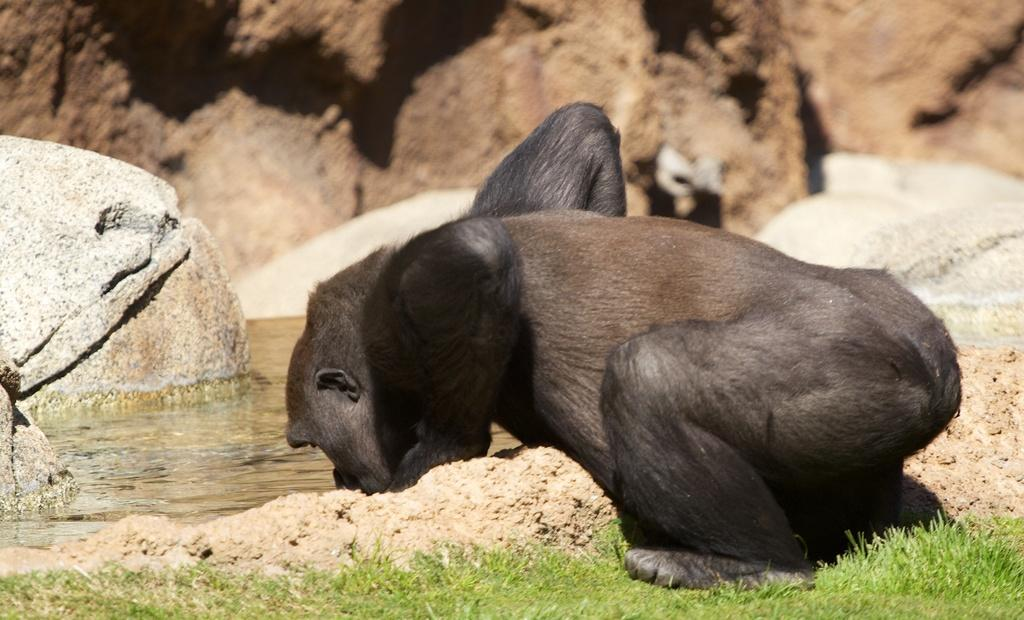What animal can be seen in the image? There is a gorilla in the image. What is the gorilla doing in the image? The gorilla is drinking water. What type of vegetation is present in the image? There is grass in the image. What other objects can be seen in the image? There are rocks in the image. How would you describe the background of the image? The background of the image is blurred. What idea does the gorilla have while drinking water in the image? There is no indication in the image that the gorilla has any ideas. --- Facts: 1. There is a person in the image. 12. The person is wearing a hat. 13. The person is holding a book. 14. There is a tree in the background. 15. The ground is visible in the image. Absurd Topics: 16. elephant, 17. bicycle, 18. umbrella Conversation: What is the main subject in the image? There is a person in the image. What is the person wearing in the image? The person is wearing a hat. What object is the person holding in the image? The person is holding a book. What can be seen in the background of the image? There is a tree in the background. What part of the natural environment is visible in the image? The ground is visible in the image. Reasoning: Let's think step by step in order to produce the conversation. We start by identifying the main subject of the image, which is a person. Next, we describe specific features of the person, such as the hat. Then, we observe the actions of the person, noting that they are holding a book. Finally, we describe the natural setting visible in the image, which includes a tree in the background and the ground. Absurd Question/Answer: How many elephants can be seen holding a bicycle in the image? There are no elephants or bicycles present in the image. --- Facts: 11. There is a cat in the image. 12. The cat is sitting on a chair. 13. The cat is looking at a bird. 14. There is a window in the background. 15. The cat is indoors. Absurd Topics: 16. refrigerator, 17. television, 18. vacuum cleaner Conversation: What type of animal can be seen in the image? There is a cat in the image. What is the cat doing in the image? The cat is sitting on a chair. What is the cat looking at in the image? The cat is looking at a bird 